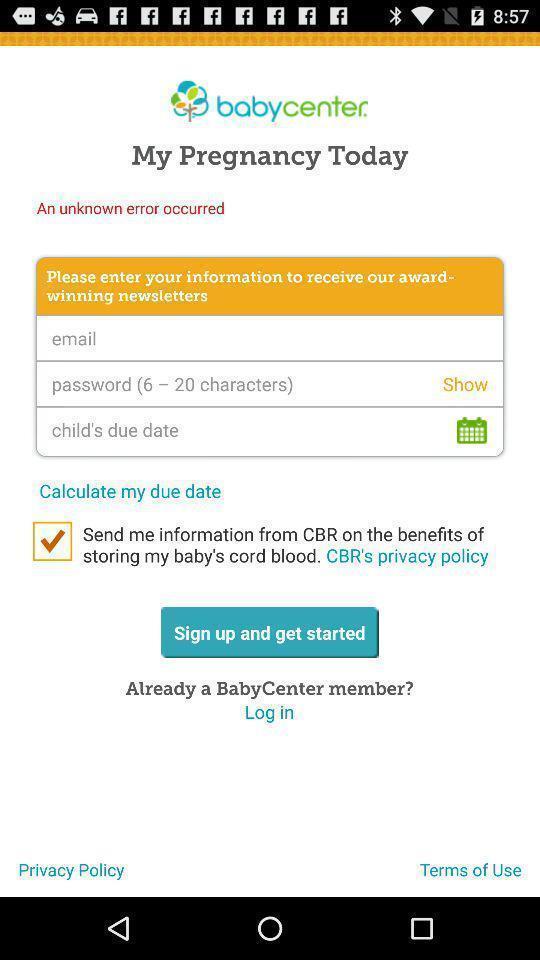Summarize the main components in this picture. Sign up page of a social app. 